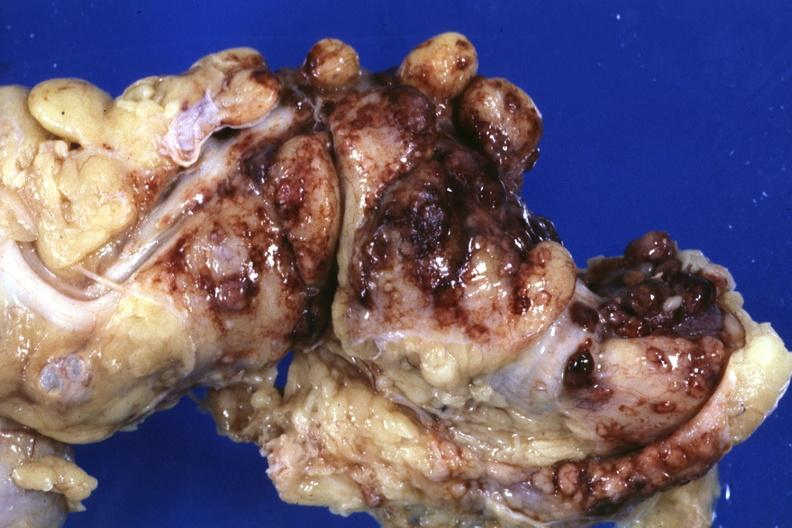does this image show fixed tissue?
Answer the question using a single word or phrase. Yes 